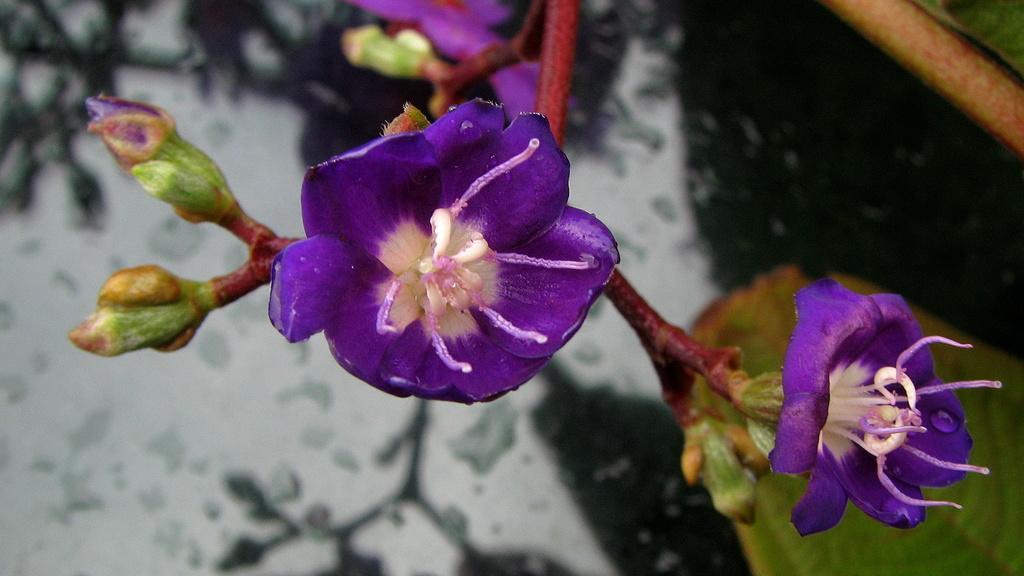Can you describe this image briefly? In this image there are flowers, buds, leaves and stems. 